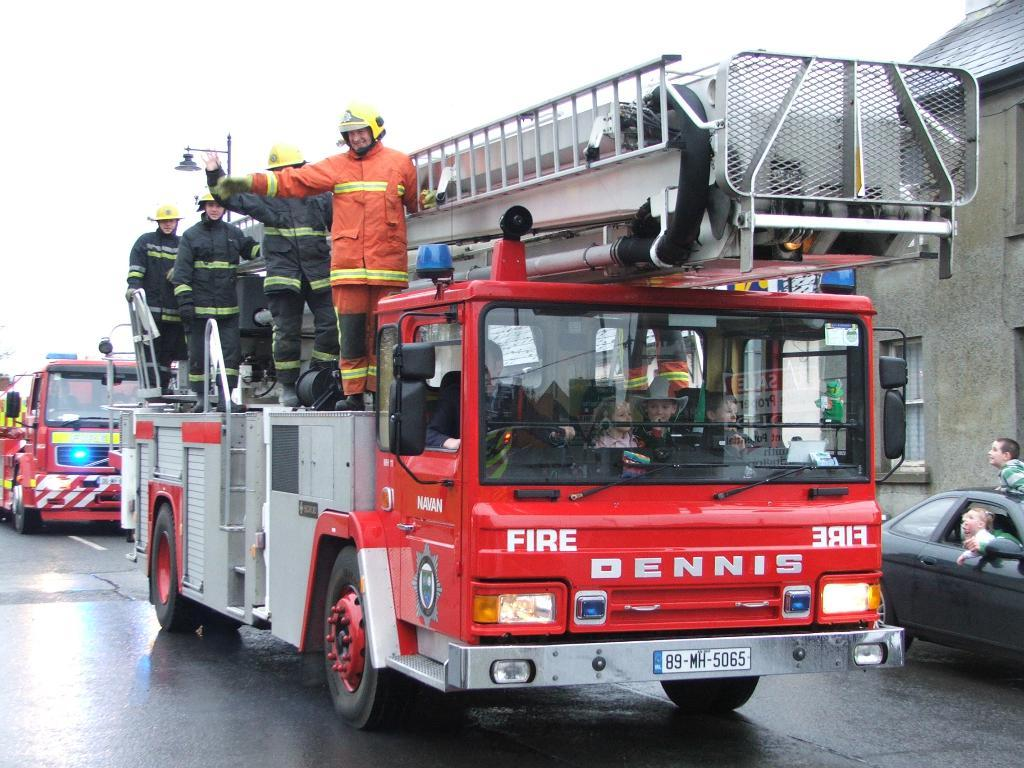What type of vehicles are present in the image? There are fire vehicles in the image. What are the people near the fire vehicles doing? There are people standing near the fire vehicles. What can be seen on the right side of the image? There is a car on the right side of the image. What is the color of the car? The car is black in color. Are there any people inside the car? Yes, there are people sitting in the car. What type of chicken can be seen on the farm in the image? There is no chicken or farm present in the image; it features fire vehicles, people, and a car. What type of oatmeal is being served to the people sitting in the car? There is no oatmeal or indication of food being served in the image. 